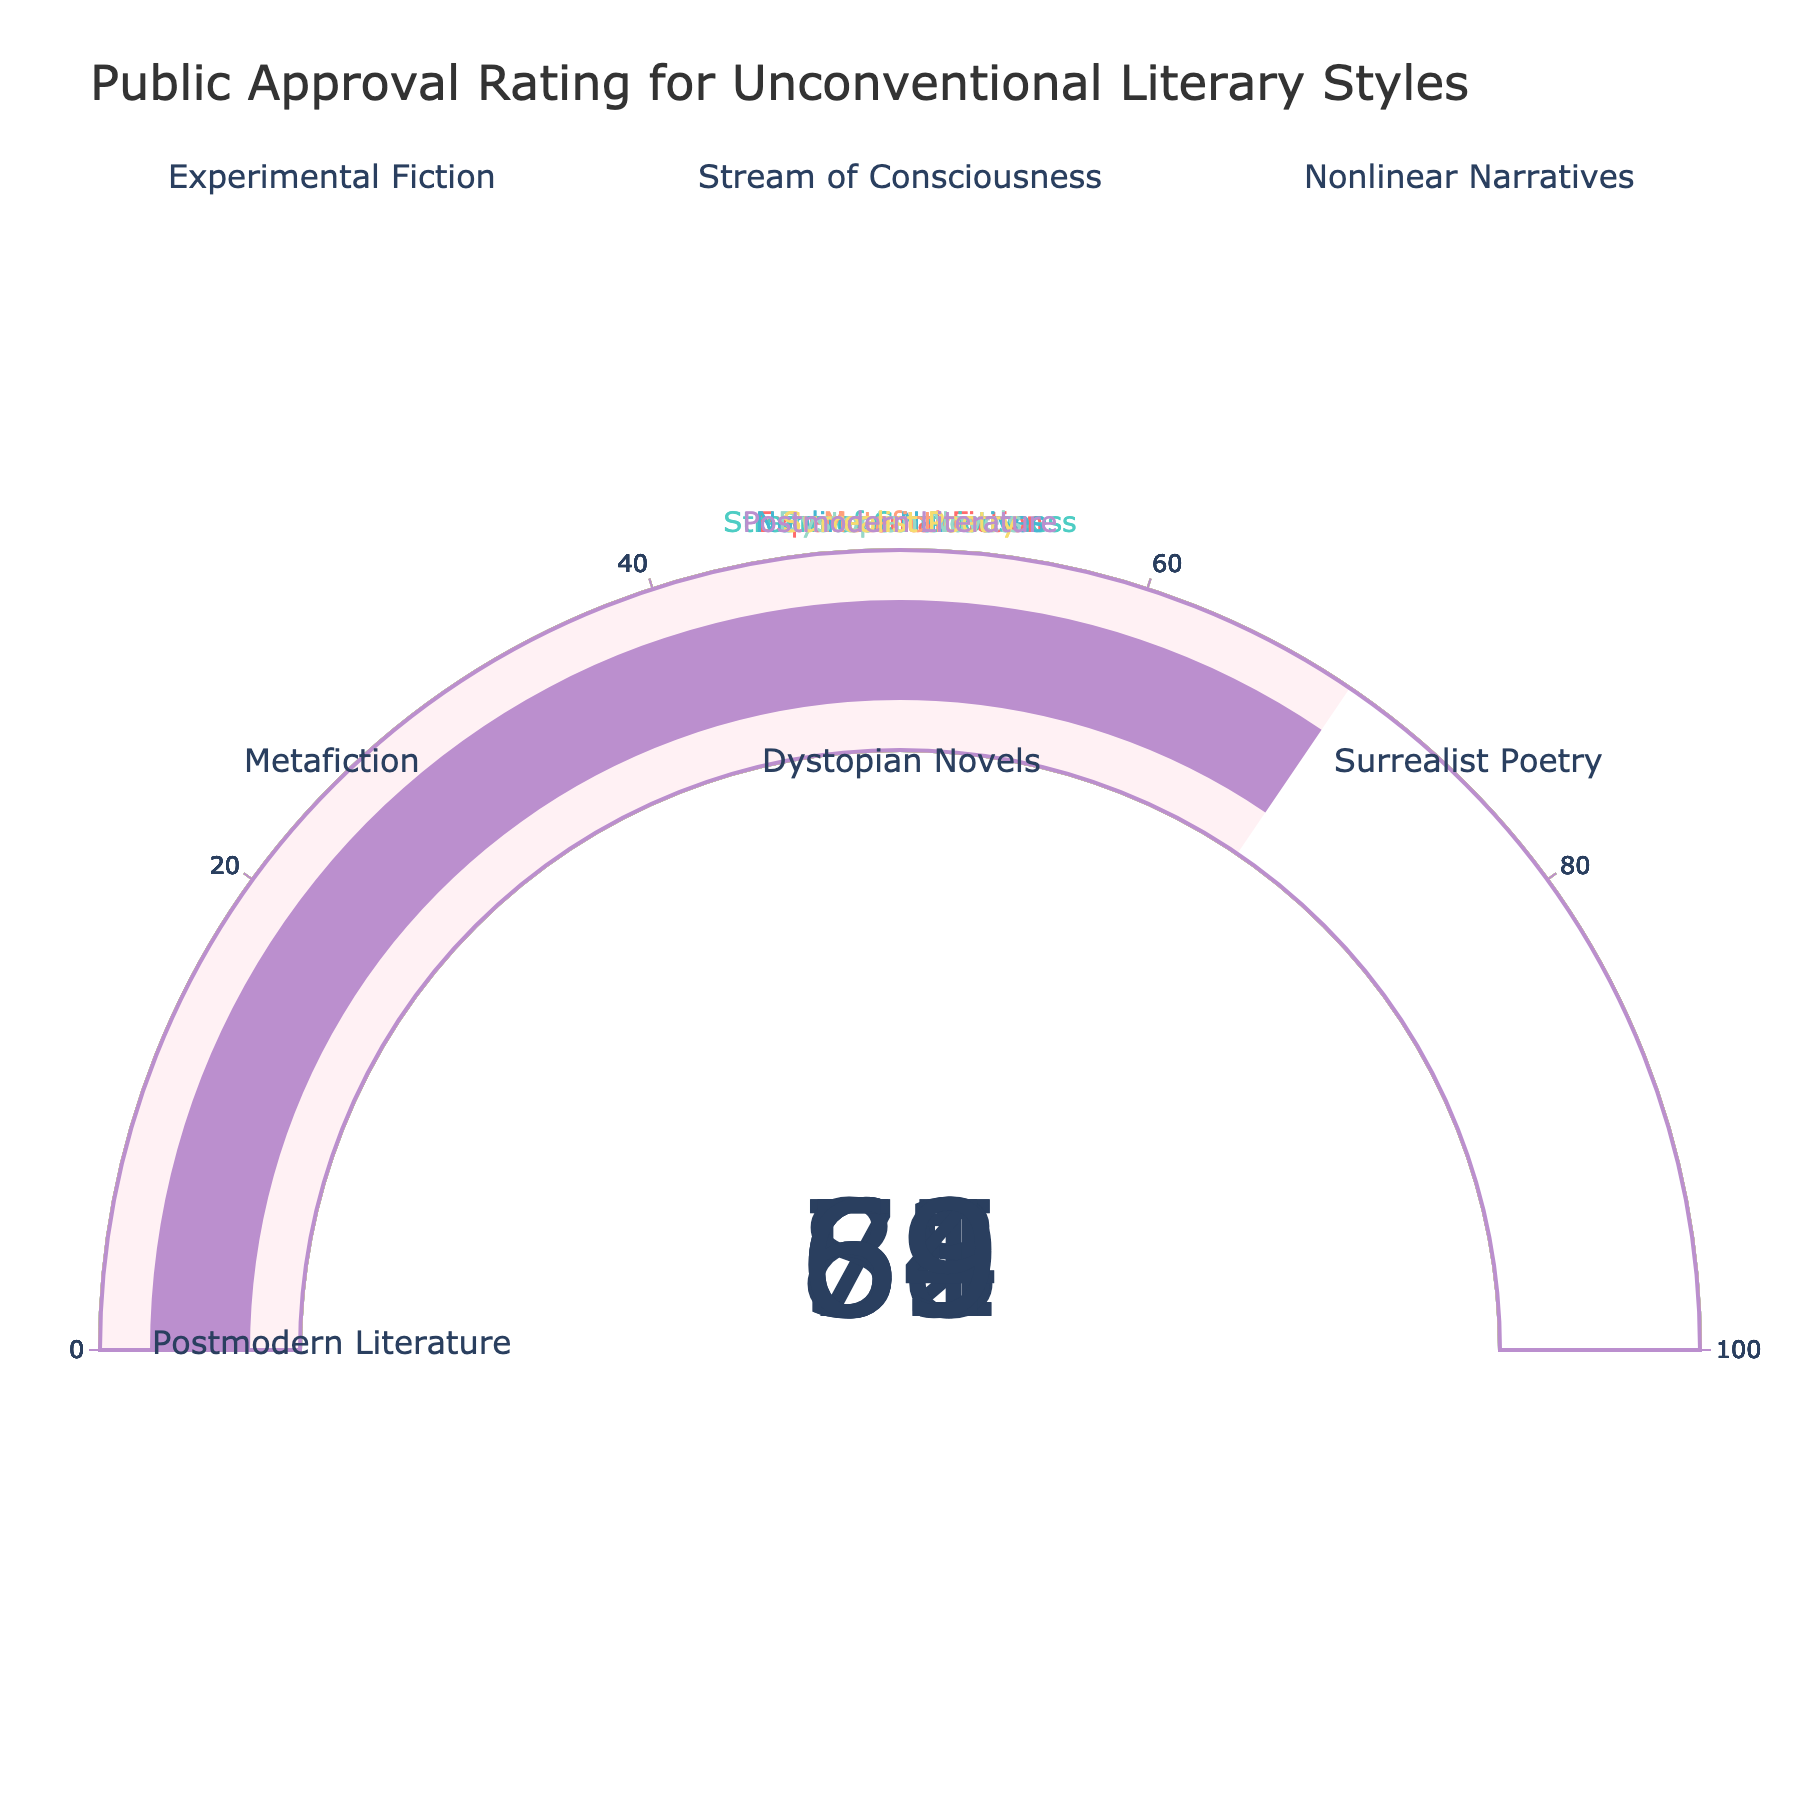What's the highest approval rating in the figure? The highest approval rating can be determined by looking at the numerical values displayed on the gauge charts. Among all, the "Dystopian Novels" category has the highest rating of 83.
Answer: 83 Which category has the lowest approval rating? The lowest approval rating is found by comparing the numerical values of each category. The "Surrealist Poetry" category has the lowest rating of 54.
Answer: 54 What is the title of the figure? The title of the figure is shown at the top and reads "Public Approval Rating for Unconventional Literary Styles".
Answer: Public Approval Rating for Unconventional Literary Styles How much higher is the approval rating for "Experimental Fiction" compared to "Stream of Consciousness"? The approval rating for "Experimental Fiction" is 72, and for "Stream of Consciousness" it is 65. The difference is calculated by subtracting 65 from 72.
Answer: 7 What is the average approval rating across all literary styles shown? Summing all the approval values: 72, 65, 58, 61, 83, 54, 69 (total = 462). Dividing by the number of categories (7) gives the average approval rating: 462/7 = 66.
Answer: 66 Which literary style falls in the middle range of approval ratings? Sorting the approval ratings (54, 58, 61, 65, 69, 72, 83), the middle value (median) is 65, corresponding to "Stream of Consciousness".
Answer: Stream of Consciousness What is the combined approval rating for "Metafiction" and "Postmodern Literature"? The approval rating for "Metafiction" is 61 and for "Postmodern Literature" is 69. Adding these gives 61 + 69 = 130.
Answer: 130 Which category has an approval rating closest to 60? Comparing the values closest to 60, we see "Metafiction" with a 61 rating is closest.
Answer: Metafiction Is there any category with an approval rating exactly between 50 and 60? Yes, "Surrealist Poetry" has an approval rating of 54, which lies between 50 and 60.
Answer: Surrealist Poetry 